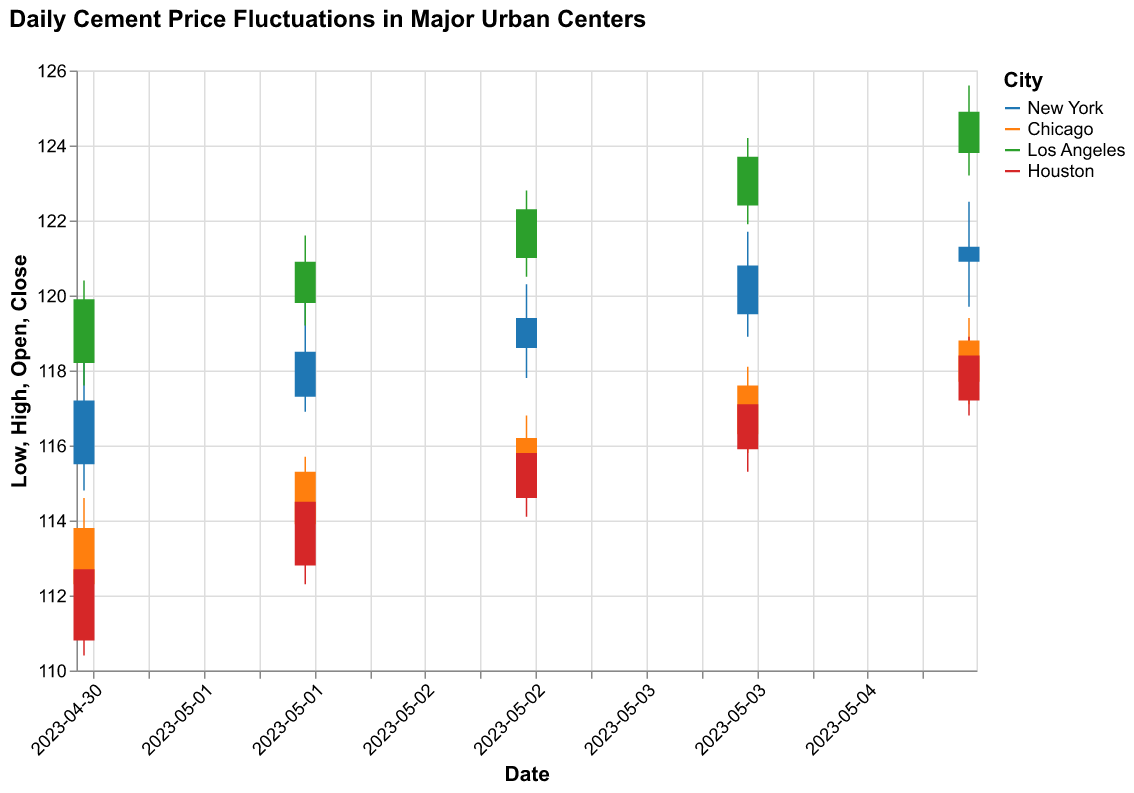What is the title of the chart? The title of the chart is prominently displayed at the top.
Answer: Daily Cement Price Fluctuations in Major Urban Centers On which date was the highest closing price for Los Angeles recorded? To find the highest closing price for Los Angeles, look for the highest 'Close' value corresponding to Los Angeles.
Answer: May 5, 2023 What are the colors representing New York and Houston in the chart? The legend to the right shows the colors representing each city. New York is represented by blue, and Houston by red.
Answer: Blue and Red What is the difference between the opening and closing prices for Chicago on May 4, 2023? Locate May 4, 2023, for Chicago and subtract the 'Open' price from the 'Close' price to find the difference. Open: 116.30 and Close: 117.60. The difference is 117.60 - 116.30 = 1.30.
Answer: 1.30 Which city had the lowest low price on May 1, 2023? For May 1, 2023, compare the 'Low' prices of all cities and identify the city with the lowest value. Houston had the lowest value with a 'Low' price of 110.40.
Answer: Houston What was the average closing price in New York for the given dates? Sum the closing prices for New York on each date and divide by the number of dates. (117.20 + 118.50 + 119.40 + 120.80 + 121.30) / 5 = 119.84.
Answer: 119.84 Did any city have a consistent increase in closing price from May 1 to May 5, 2023? Check the closing prices of each city for the given dates. Los Angeles shows a consistent increase.
Answer: Los Angeles Compare the price range (High - Low) for Houston on May 3 and May 4, 2023. Which day had a greater range? Calculate the price range for both dates by subtracting 'Low' from 'High' for each day. May 3 range: 116.20 - 114.10 = 2.10, May 4 range: 117.50 - 115.30 = 2.20. May 4 has a greater range.
Answer: May 4, 2023 What is the highest high price recorded in the data set? Identify the maximum 'High' price across all dates and cities by scanning the 'High' values. The highest is 125.60 recorded in Los Angeles on May 5, 2023.
Answer: 125.60 